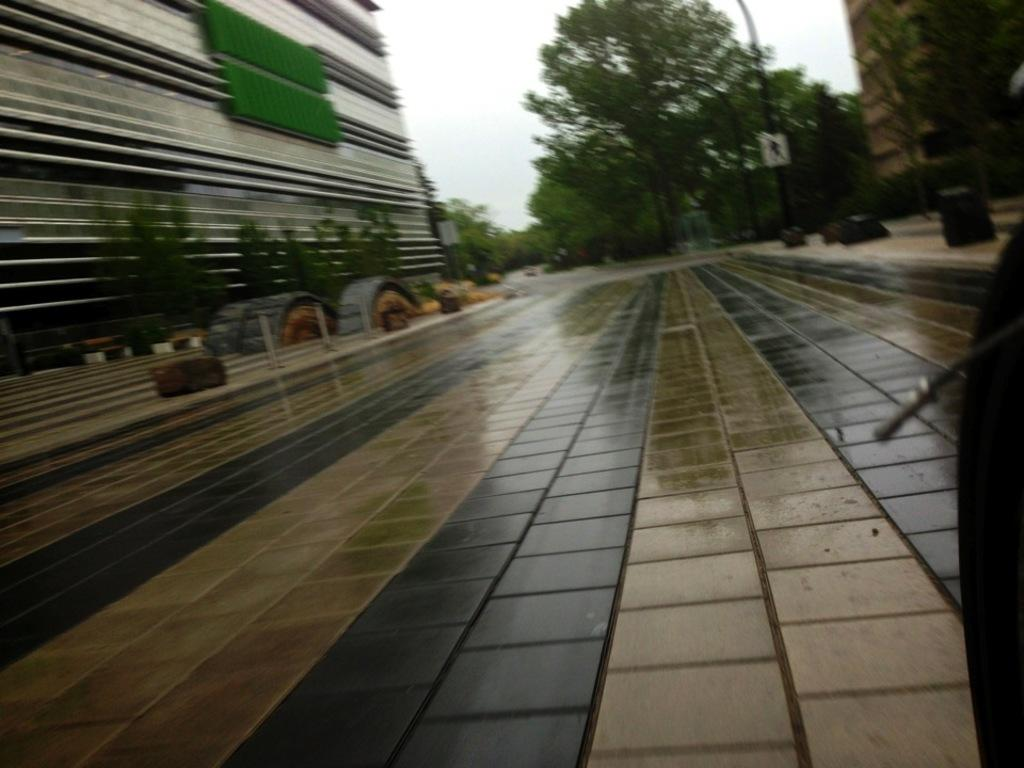What type of surface can be seen in the image? Floors are visible in the image. What might be used to separate or protect certain areas in the image? There are barriers in the image. What type of structures are present in the image? There are buildings in the image. What type of vertical structures can be seen in the image? Street poles are present in the image. What type of vegetation is visible in the image? Trees are visible in the image. What part of the natural environment is visible in the image? The sky is visible in the image. What color is the crayon being used by the coach in the image? There is no coach or crayon present in the image. What type of offer is being made by the person in the image? There is no person making an offer in the image. 